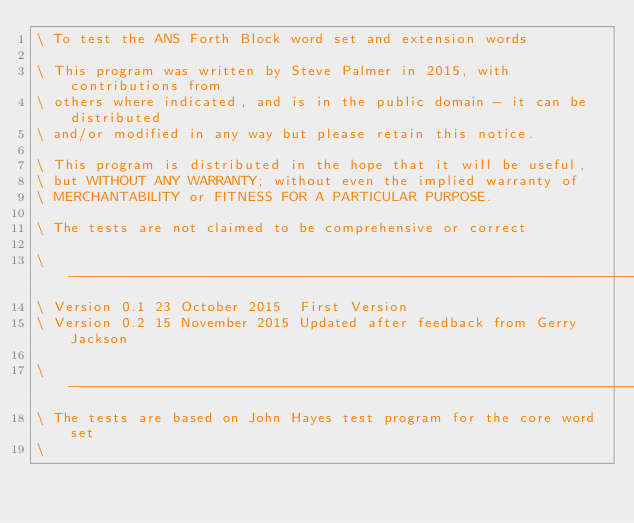<code> <loc_0><loc_0><loc_500><loc_500><_Forth_>\ To test the ANS Forth Block word set and extension words

\ This program was written by Steve Palmer in 2015, with contributions from
\ others where indicated, and is in the public domain - it can be distributed
\ and/or modified in any way but please retain this notice.

\ This program is distributed in the hope that it will be useful,
\ but WITHOUT ANY WARRANTY; without even the implied warranty of
\ MERCHANTABILITY or FITNESS FOR A PARTICULAR PURPOSE.

\ The tests are not claimed to be comprehensive or correct

\ ------------------------------------------------------------------------------
\ Version 0.1 23 October 2015  First Version
\ Version 0.2 15 November 2015 Updated after feedback from Gerry Jackson

\ ------------------------------------------------------------------------------
\ The tests are based on John Hayes test program for the core word set
\</code> 